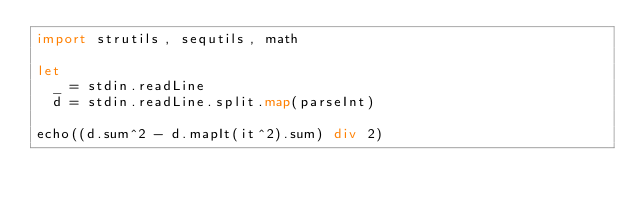Convert code to text. <code><loc_0><loc_0><loc_500><loc_500><_Nim_>import strutils, sequtils, math

let
  _ = stdin.readLine
  d = stdin.readLine.split.map(parseInt)

echo((d.sum^2 - d.mapIt(it^2).sum) div 2)
</code> 